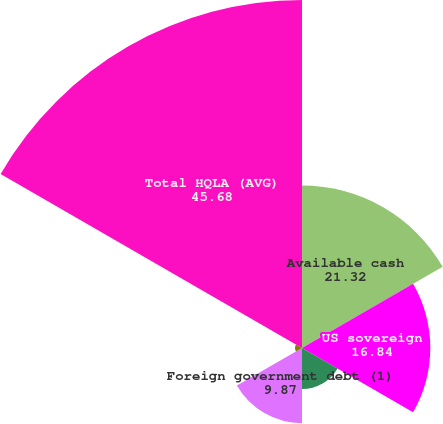<chart> <loc_0><loc_0><loc_500><loc_500><pie_chart><fcel>Available cash<fcel>US sovereign<fcel>US agency/agency MBS<fcel>Foreign government debt (1)<fcel>Other investment grade<fcel>Total HQLA (AVG)<nl><fcel>21.32%<fcel>16.84%<fcel>5.39%<fcel>9.87%<fcel>0.91%<fcel>45.68%<nl></chart> 